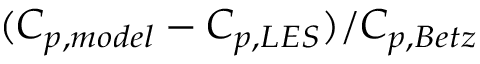<formula> <loc_0><loc_0><loc_500><loc_500>( C _ { p , m o d e l } - C _ { p , L E S } ) / C _ { p , B e t z }</formula> 